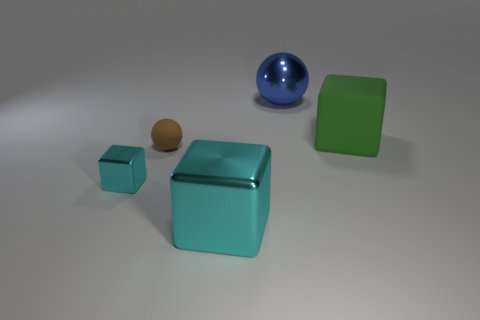What size is the thing that is the same color as the big shiny cube?
Keep it short and to the point. Small. There is a metallic thing behind the tiny brown sphere; what shape is it?
Your answer should be very brief. Sphere. There is a metallic thing that is the same size as the brown ball; what color is it?
Make the answer very short. Cyan. Is the material of the big thing that is in front of the big green cube the same as the brown sphere?
Provide a short and direct response. No. There is a block that is to the right of the brown object and left of the green block; what size is it?
Your answer should be very brief. Large. There is a thing on the right side of the big blue sphere; what is its size?
Provide a short and direct response. Large. There is a large metal object that is the same color as the tiny metallic object; what is its shape?
Your answer should be compact. Cube. The cyan thing behind the metal cube to the right of the metallic object to the left of the brown object is what shape?
Offer a terse response. Cube. What number of other things are the same shape as the tiny cyan metallic object?
Your response must be concise. 2. What number of metallic things are small objects or small blue spheres?
Your response must be concise. 1. 